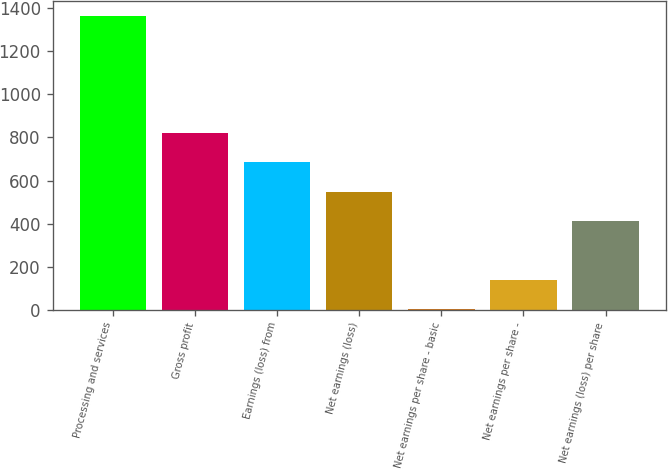<chart> <loc_0><loc_0><loc_500><loc_500><bar_chart><fcel>Processing and services<fcel>Gross profit<fcel>Earnings (loss) from<fcel>Net earnings (loss)<fcel>Net earnings per share - basic<fcel>Net earnings per share -<fcel>Net earnings (loss) per share<nl><fcel>1367.2<fcel>820.47<fcel>683.78<fcel>547.09<fcel>0.33<fcel>137.02<fcel>410.4<nl></chart> 